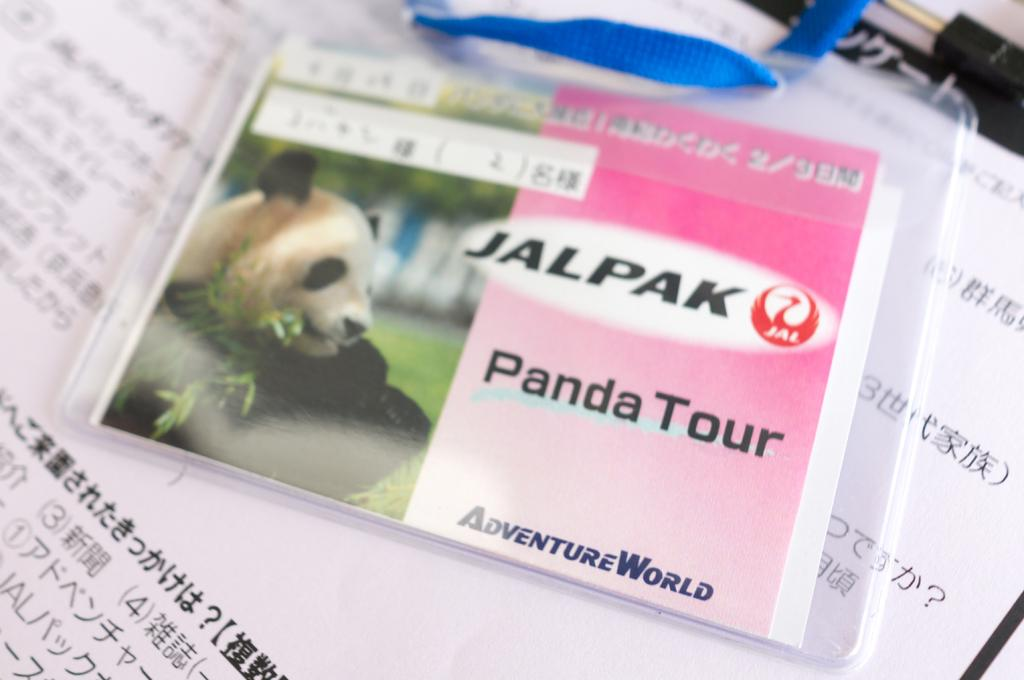What is attached to the paper in the image? There is a tag on the paper in the image. What else is on the paper besides the tag? There is a card on the paper. What image can be seen on the card? There is an image of a panda on the card. How many rods are visible in the image? There are no rods present in the image. What type of lace can be seen on the card? There is no lace present on the card; it features an image of a panda. 